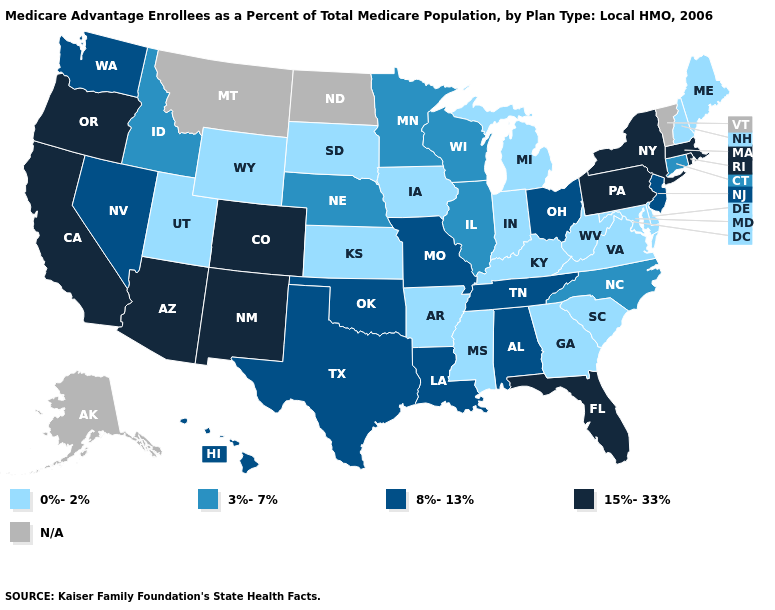Name the states that have a value in the range 15%-33%?
Answer briefly. Arizona, California, Colorado, Florida, Massachusetts, New Mexico, New York, Oregon, Pennsylvania, Rhode Island. Does New York have the lowest value in the Northeast?
Answer briefly. No. Name the states that have a value in the range N/A?
Write a very short answer. Alaska, Montana, North Dakota, Vermont. What is the value of Florida?
Concise answer only. 15%-33%. Which states have the lowest value in the South?
Answer briefly. Arkansas, Delaware, Georgia, Kentucky, Maryland, Mississippi, South Carolina, Virginia, West Virginia. What is the value of Maine?
Be succinct. 0%-2%. Among the states that border Pennsylvania , does West Virginia have the highest value?
Be succinct. No. Is the legend a continuous bar?
Give a very brief answer. No. Name the states that have a value in the range 0%-2%?
Concise answer only. Arkansas, Delaware, Georgia, Iowa, Indiana, Kansas, Kentucky, Maryland, Maine, Michigan, Mississippi, New Hampshire, South Carolina, South Dakota, Utah, Virginia, West Virginia, Wyoming. Which states have the lowest value in the West?
Quick response, please. Utah, Wyoming. What is the value of Nevada?
Concise answer only. 8%-13%. What is the lowest value in the MidWest?
Answer briefly. 0%-2%. 